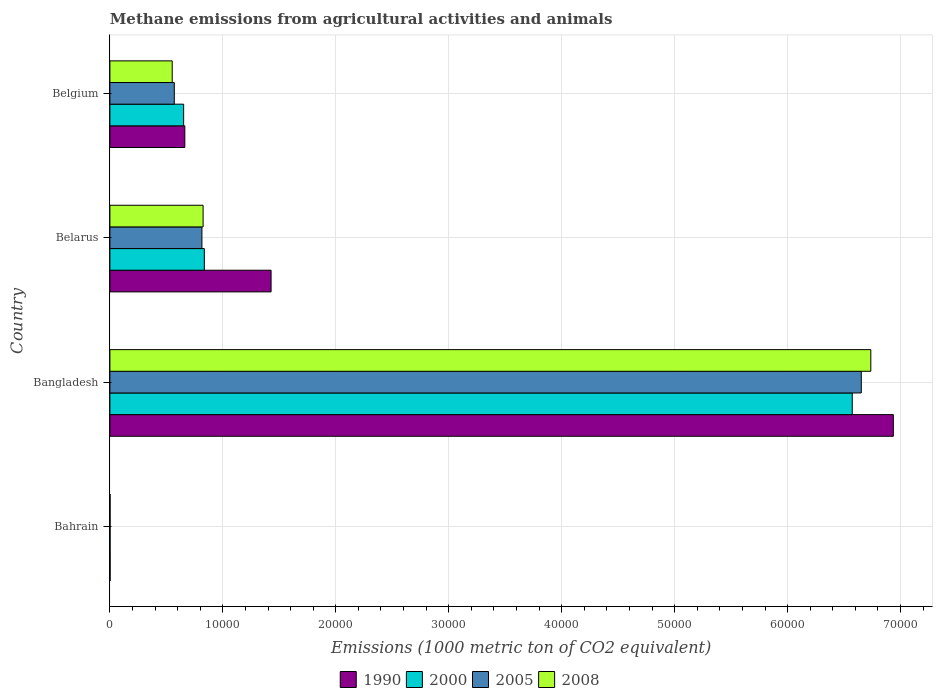How many different coloured bars are there?
Your answer should be compact. 4. Are the number of bars per tick equal to the number of legend labels?
Ensure brevity in your answer.  Yes. Are the number of bars on each tick of the Y-axis equal?
Keep it short and to the point. Yes. How many bars are there on the 2nd tick from the top?
Provide a short and direct response. 4. In how many cases, is the number of bars for a given country not equal to the number of legend labels?
Your answer should be compact. 0. What is the amount of methane emitted in 2008 in Bangladesh?
Your answer should be compact. 6.74e+04. Across all countries, what is the maximum amount of methane emitted in 2000?
Make the answer very short. 6.57e+04. In which country was the amount of methane emitted in 2005 maximum?
Offer a terse response. Bangladesh. In which country was the amount of methane emitted in 1990 minimum?
Make the answer very short. Bahrain. What is the total amount of methane emitted in 2005 in the graph?
Give a very brief answer. 8.04e+04. What is the difference between the amount of methane emitted in 2000 in Bangladesh and that in Belarus?
Make the answer very short. 5.74e+04. What is the difference between the amount of methane emitted in 2005 in Bahrain and the amount of methane emitted in 2000 in Belarus?
Your response must be concise. -8342.9. What is the average amount of methane emitted in 2000 per country?
Provide a short and direct response. 2.02e+04. What is the difference between the amount of methane emitted in 2008 and amount of methane emitted in 2005 in Belarus?
Provide a succinct answer. 104.3. In how many countries, is the amount of methane emitted in 2000 greater than 22000 1000 metric ton?
Offer a very short reply. 1. What is the ratio of the amount of methane emitted in 2000 in Bahrain to that in Belgium?
Offer a very short reply. 0. Is the difference between the amount of methane emitted in 2008 in Bangladesh and Belgium greater than the difference between the amount of methane emitted in 2005 in Bangladesh and Belgium?
Your answer should be compact. Yes. What is the difference between the highest and the second highest amount of methane emitted in 2005?
Offer a very short reply. 5.84e+04. What is the difference between the highest and the lowest amount of methane emitted in 2000?
Offer a very short reply. 6.57e+04. Is the sum of the amount of methane emitted in 2000 in Bangladesh and Belgium greater than the maximum amount of methane emitted in 1990 across all countries?
Your answer should be compact. Yes. Is it the case that in every country, the sum of the amount of methane emitted in 1990 and amount of methane emitted in 2005 is greater than the sum of amount of methane emitted in 2000 and amount of methane emitted in 2008?
Your response must be concise. No. What does the 2nd bar from the top in Bangladesh represents?
Give a very brief answer. 2005. How many bars are there?
Keep it short and to the point. 16. How many countries are there in the graph?
Keep it short and to the point. 4. What is the difference between two consecutive major ticks on the X-axis?
Offer a very short reply. 10000. Does the graph contain any zero values?
Make the answer very short. No. Does the graph contain grids?
Keep it short and to the point. Yes. What is the title of the graph?
Make the answer very short. Methane emissions from agricultural activities and animals. Does "1985" appear as one of the legend labels in the graph?
Ensure brevity in your answer.  No. What is the label or title of the X-axis?
Offer a terse response. Emissions (1000 metric ton of CO2 equivalent). What is the label or title of the Y-axis?
Provide a short and direct response. Country. What is the Emissions (1000 metric ton of CO2 equivalent) of 2005 in Bahrain?
Keep it short and to the point. 17.5. What is the Emissions (1000 metric ton of CO2 equivalent) in 2008 in Bahrain?
Offer a very short reply. 16.2. What is the Emissions (1000 metric ton of CO2 equivalent) in 1990 in Bangladesh?
Your answer should be compact. 6.94e+04. What is the Emissions (1000 metric ton of CO2 equivalent) of 2000 in Bangladesh?
Provide a succinct answer. 6.57e+04. What is the Emissions (1000 metric ton of CO2 equivalent) of 2005 in Bangladesh?
Your answer should be very brief. 6.65e+04. What is the Emissions (1000 metric ton of CO2 equivalent) in 2008 in Bangladesh?
Your answer should be very brief. 6.74e+04. What is the Emissions (1000 metric ton of CO2 equivalent) of 1990 in Belarus?
Keep it short and to the point. 1.43e+04. What is the Emissions (1000 metric ton of CO2 equivalent) in 2000 in Belarus?
Make the answer very short. 8360.4. What is the Emissions (1000 metric ton of CO2 equivalent) of 2005 in Belarus?
Ensure brevity in your answer.  8147.7. What is the Emissions (1000 metric ton of CO2 equivalent) in 2008 in Belarus?
Give a very brief answer. 8252. What is the Emissions (1000 metric ton of CO2 equivalent) of 1990 in Belgium?
Make the answer very short. 6634.3. What is the Emissions (1000 metric ton of CO2 equivalent) in 2000 in Belgium?
Make the answer very short. 6529.5. What is the Emissions (1000 metric ton of CO2 equivalent) of 2005 in Belgium?
Provide a short and direct response. 5701.8. What is the Emissions (1000 metric ton of CO2 equivalent) of 2008 in Belgium?
Your answer should be very brief. 5517.1. Across all countries, what is the maximum Emissions (1000 metric ton of CO2 equivalent) in 1990?
Provide a succinct answer. 6.94e+04. Across all countries, what is the maximum Emissions (1000 metric ton of CO2 equivalent) of 2000?
Your response must be concise. 6.57e+04. Across all countries, what is the maximum Emissions (1000 metric ton of CO2 equivalent) of 2005?
Your response must be concise. 6.65e+04. Across all countries, what is the maximum Emissions (1000 metric ton of CO2 equivalent) of 2008?
Provide a short and direct response. 6.74e+04. Across all countries, what is the minimum Emissions (1000 metric ton of CO2 equivalent) of 1990?
Make the answer very short. 19.5. Across all countries, what is the minimum Emissions (1000 metric ton of CO2 equivalent) in 2000?
Provide a succinct answer. 18.5. Across all countries, what is the minimum Emissions (1000 metric ton of CO2 equivalent) of 2005?
Ensure brevity in your answer.  17.5. What is the total Emissions (1000 metric ton of CO2 equivalent) in 1990 in the graph?
Give a very brief answer. 9.03e+04. What is the total Emissions (1000 metric ton of CO2 equivalent) of 2000 in the graph?
Your answer should be very brief. 8.06e+04. What is the total Emissions (1000 metric ton of CO2 equivalent) of 2005 in the graph?
Ensure brevity in your answer.  8.04e+04. What is the total Emissions (1000 metric ton of CO2 equivalent) of 2008 in the graph?
Give a very brief answer. 8.11e+04. What is the difference between the Emissions (1000 metric ton of CO2 equivalent) of 1990 in Bahrain and that in Bangladesh?
Your answer should be compact. -6.93e+04. What is the difference between the Emissions (1000 metric ton of CO2 equivalent) of 2000 in Bahrain and that in Bangladesh?
Make the answer very short. -6.57e+04. What is the difference between the Emissions (1000 metric ton of CO2 equivalent) of 2005 in Bahrain and that in Bangladesh?
Make the answer very short. -6.65e+04. What is the difference between the Emissions (1000 metric ton of CO2 equivalent) in 2008 in Bahrain and that in Bangladesh?
Offer a very short reply. -6.73e+04. What is the difference between the Emissions (1000 metric ton of CO2 equivalent) in 1990 in Bahrain and that in Belarus?
Your response must be concise. -1.43e+04. What is the difference between the Emissions (1000 metric ton of CO2 equivalent) of 2000 in Bahrain and that in Belarus?
Keep it short and to the point. -8341.9. What is the difference between the Emissions (1000 metric ton of CO2 equivalent) of 2005 in Bahrain and that in Belarus?
Offer a terse response. -8130.2. What is the difference between the Emissions (1000 metric ton of CO2 equivalent) in 2008 in Bahrain and that in Belarus?
Your answer should be very brief. -8235.8. What is the difference between the Emissions (1000 metric ton of CO2 equivalent) of 1990 in Bahrain and that in Belgium?
Give a very brief answer. -6614.8. What is the difference between the Emissions (1000 metric ton of CO2 equivalent) in 2000 in Bahrain and that in Belgium?
Your answer should be compact. -6511. What is the difference between the Emissions (1000 metric ton of CO2 equivalent) of 2005 in Bahrain and that in Belgium?
Ensure brevity in your answer.  -5684.3. What is the difference between the Emissions (1000 metric ton of CO2 equivalent) of 2008 in Bahrain and that in Belgium?
Your answer should be compact. -5500.9. What is the difference between the Emissions (1000 metric ton of CO2 equivalent) of 1990 in Bangladesh and that in Belarus?
Give a very brief answer. 5.51e+04. What is the difference between the Emissions (1000 metric ton of CO2 equivalent) in 2000 in Bangladesh and that in Belarus?
Your response must be concise. 5.74e+04. What is the difference between the Emissions (1000 metric ton of CO2 equivalent) of 2005 in Bangladesh and that in Belarus?
Ensure brevity in your answer.  5.84e+04. What is the difference between the Emissions (1000 metric ton of CO2 equivalent) of 2008 in Bangladesh and that in Belarus?
Ensure brevity in your answer.  5.91e+04. What is the difference between the Emissions (1000 metric ton of CO2 equivalent) of 1990 in Bangladesh and that in Belgium?
Provide a succinct answer. 6.27e+04. What is the difference between the Emissions (1000 metric ton of CO2 equivalent) of 2000 in Bangladesh and that in Belgium?
Give a very brief answer. 5.92e+04. What is the difference between the Emissions (1000 metric ton of CO2 equivalent) in 2005 in Bangladesh and that in Belgium?
Offer a terse response. 6.08e+04. What is the difference between the Emissions (1000 metric ton of CO2 equivalent) in 2008 in Bangladesh and that in Belgium?
Your answer should be compact. 6.18e+04. What is the difference between the Emissions (1000 metric ton of CO2 equivalent) in 1990 in Belarus and that in Belgium?
Make the answer very short. 7636. What is the difference between the Emissions (1000 metric ton of CO2 equivalent) in 2000 in Belarus and that in Belgium?
Your answer should be very brief. 1830.9. What is the difference between the Emissions (1000 metric ton of CO2 equivalent) of 2005 in Belarus and that in Belgium?
Your answer should be compact. 2445.9. What is the difference between the Emissions (1000 metric ton of CO2 equivalent) of 2008 in Belarus and that in Belgium?
Provide a succinct answer. 2734.9. What is the difference between the Emissions (1000 metric ton of CO2 equivalent) of 1990 in Bahrain and the Emissions (1000 metric ton of CO2 equivalent) of 2000 in Bangladesh?
Offer a terse response. -6.57e+04. What is the difference between the Emissions (1000 metric ton of CO2 equivalent) of 1990 in Bahrain and the Emissions (1000 metric ton of CO2 equivalent) of 2005 in Bangladesh?
Your answer should be very brief. -6.65e+04. What is the difference between the Emissions (1000 metric ton of CO2 equivalent) of 1990 in Bahrain and the Emissions (1000 metric ton of CO2 equivalent) of 2008 in Bangladesh?
Offer a very short reply. -6.73e+04. What is the difference between the Emissions (1000 metric ton of CO2 equivalent) in 2000 in Bahrain and the Emissions (1000 metric ton of CO2 equivalent) in 2005 in Bangladesh?
Keep it short and to the point. -6.65e+04. What is the difference between the Emissions (1000 metric ton of CO2 equivalent) of 2000 in Bahrain and the Emissions (1000 metric ton of CO2 equivalent) of 2008 in Bangladesh?
Your response must be concise. -6.73e+04. What is the difference between the Emissions (1000 metric ton of CO2 equivalent) of 2005 in Bahrain and the Emissions (1000 metric ton of CO2 equivalent) of 2008 in Bangladesh?
Your answer should be compact. -6.73e+04. What is the difference between the Emissions (1000 metric ton of CO2 equivalent) in 1990 in Bahrain and the Emissions (1000 metric ton of CO2 equivalent) in 2000 in Belarus?
Your response must be concise. -8340.9. What is the difference between the Emissions (1000 metric ton of CO2 equivalent) in 1990 in Bahrain and the Emissions (1000 metric ton of CO2 equivalent) in 2005 in Belarus?
Make the answer very short. -8128.2. What is the difference between the Emissions (1000 metric ton of CO2 equivalent) of 1990 in Bahrain and the Emissions (1000 metric ton of CO2 equivalent) of 2008 in Belarus?
Give a very brief answer. -8232.5. What is the difference between the Emissions (1000 metric ton of CO2 equivalent) of 2000 in Bahrain and the Emissions (1000 metric ton of CO2 equivalent) of 2005 in Belarus?
Offer a very short reply. -8129.2. What is the difference between the Emissions (1000 metric ton of CO2 equivalent) of 2000 in Bahrain and the Emissions (1000 metric ton of CO2 equivalent) of 2008 in Belarus?
Ensure brevity in your answer.  -8233.5. What is the difference between the Emissions (1000 metric ton of CO2 equivalent) of 2005 in Bahrain and the Emissions (1000 metric ton of CO2 equivalent) of 2008 in Belarus?
Your answer should be compact. -8234.5. What is the difference between the Emissions (1000 metric ton of CO2 equivalent) of 1990 in Bahrain and the Emissions (1000 metric ton of CO2 equivalent) of 2000 in Belgium?
Offer a very short reply. -6510. What is the difference between the Emissions (1000 metric ton of CO2 equivalent) of 1990 in Bahrain and the Emissions (1000 metric ton of CO2 equivalent) of 2005 in Belgium?
Ensure brevity in your answer.  -5682.3. What is the difference between the Emissions (1000 metric ton of CO2 equivalent) in 1990 in Bahrain and the Emissions (1000 metric ton of CO2 equivalent) in 2008 in Belgium?
Keep it short and to the point. -5497.6. What is the difference between the Emissions (1000 metric ton of CO2 equivalent) of 2000 in Bahrain and the Emissions (1000 metric ton of CO2 equivalent) of 2005 in Belgium?
Offer a terse response. -5683.3. What is the difference between the Emissions (1000 metric ton of CO2 equivalent) in 2000 in Bahrain and the Emissions (1000 metric ton of CO2 equivalent) in 2008 in Belgium?
Provide a succinct answer. -5498.6. What is the difference between the Emissions (1000 metric ton of CO2 equivalent) of 2005 in Bahrain and the Emissions (1000 metric ton of CO2 equivalent) of 2008 in Belgium?
Keep it short and to the point. -5499.6. What is the difference between the Emissions (1000 metric ton of CO2 equivalent) in 1990 in Bangladesh and the Emissions (1000 metric ton of CO2 equivalent) in 2000 in Belarus?
Offer a very short reply. 6.10e+04. What is the difference between the Emissions (1000 metric ton of CO2 equivalent) in 1990 in Bangladesh and the Emissions (1000 metric ton of CO2 equivalent) in 2005 in Belarus?
Provide a short and direct response. 6.12e+04. What is the difference between the Emissions (1000 metric ton of CO2 equivalent) of 1990 in Bangladesh and the Emissions (1000 metric ton of CO2 equivalent) of 2008 in Belarus?
Keep it short and to the point. 6.11e+04. What is the difference between the Emissions (1000 metric ton of CO2 equivalent) of 2000 in Bangladesh and the Emissions (1000 metric ton of CO2 equivalent) of 2005 in Belarus?
Offer a very short reply. 5.76e+04. What is the difference between the Emissions (1000 metric ton of CO2 equivalent) in 2000 in Bangladesh and the Emissions (1000 metric ton of CO2 equivalent) in 2008 in Belarus?
Offer a terse response. 5.75e+04. What is the difference between the Emissions (1000 metric ton of CO2 equivalent) of 2005 in Bangladesh and the Emissions (1000 metric ton of CO2 equivalent) of 2008 in Belarus?
Offer a very short reply. 5.83e+04. What is the difference between the Emissions (1000 metric ton of CO2 equivalent) in 1990 in Bangladesh and the Emissions (1000 metric ton of CO2 equivalent) in 2000 in Belgium?
Provide a succinct answer. 6.28e+04. What is the difference between the Emissions (1000 metric ton of CO2 equivalent) of 1990 in Bangladesh and the Emissions (1000 metric ton of CO2 equivalent) of 2005 in Belgium?
Provide a succinct answer. 6.37e+04. What is the difference between the Emissions (1000 metric ton of CO2 equivalent) in 1990 in Bangladesh and the Emissions (1000 metric ton of CO2 equivalent) in 2008 in Belgium?
Your answer should be compact. 6.38e+04. What is the difference between the Emissions (1000 metric ton of CO2 equivalent) of 2000 in Bangladesh and the Emissions (1000 metric ton of CO2 equivalent) of 2005 in Belgium?
Offer a terse response. 6.00e+04. What is the difference between the Emissions (1000 metric ton of CO2 equivalent) of 2000 in Bangladesh and the Emissions (1000 metric ton of CO2 equivalent) of 2008 in Belgium?
Ensure brevity in your answer.  6.02e+04. What is the difference between the Emissions (1000 metric ton of CO2 equivalent) in 2005 in Bangladesh and the Emissions (1000 metric ton of CO2 equivalent) in 2008 in Belgium?
Make the answer very short. 6.10e+04. What is the difference between the Emissions (1000 metric ton of CO2 equivalent) of 1990 in Belarus and the Emissions (1000 metric ton of CO2 equivalent) of 2000 in Belgium?
Give a very brief answer. 7740.8. What is the difference between the Emissions (1000 metric ton of CO2 equivalent) of 1990 in Belarus and the Emissions (1000 metric ton of CO2 equivalent) of 2005 in Belgium?
Your answer should be very brief. 8568.5. What is the difference between the Emissions (1000 metric ton of CO2 equivalent) in 1990 in Belarus and the Emissions (1000 metric ton of CO2 equivalent) in 2008 in Belgium?
Provide a succinct answer. 8753.2. What is the difference between the Emissions (1000 metric ton of CO2 equivalent) in 2000 in Belarus and the Emissions (1000 metric ton of CO2 equivalent) in 2005 in Belgium?
Make the answer very short. 2658.6. What is the difference between the Emissions (1000 metric ton of CO2 equivalent) of 2000 in Belarus and the Emissions (1000 metric ton of CO2 equivalent) of 2008 in Belgium?
Offer a very short reply. 2843.3. What is the difference between the Emissions (1000 metric ton of CO2 equivalent) of 2005 in Belarus and the Emissions (1000 metric ton of CO2 equivalent) of 2008 in Belgium?
Offer a terse response. 2630.6. What is the average Emissions (1000 metric ton of CO2 equivalent) in 1990 per country?
Provide a short and direct response. 2.26e+04. What is the average Emissions (1000 metric ton of CO2 equivalent) in 2000 per country?
Your answer should be compact. 2.02e+04. What is the average Emissions (1000 metric ton of CO2 equivalent) in 2005 per country?
Keep it short and to the point. 2.01e+04. What is the average Emissions (1000 metric ton of CO2 equivalent) of 2008 per country?
Offer a very short reply. 2.03e+04. What is the difference between the Emissions (1000 metric ton of CO2 equivalent) in 1990 and Emissions (1000 metric ton of CO2 equivalent) in 2005 in Bahrain?
Provide a succinct answer. 2. What is the difference between the Emissions (1000 metric ton of CO2 equivalent) of 1990 and Emissions (1000 metric ton of CO2 equivalent) of 2008 in Bahrain?
Provide a succinct answer. 3.3. What is the difference between the Emissions (1000 metric ton of CO2 equivalent) of 2000 and Emissions (1000 metric ton of CO2 equivalent) of 2005 in Bahrain?
Give a very brief answer. 1. What is the difference between the Emissions (1000 metric ton of CO2 equivalent) of 2000 and Emissions (1000 metric ton of CO2 equivalent) of 2008 in Bahrain?
Your answer should be compact. 2.3. What is the difference between the Emissions (1000 metric ton of CO2 equivalent) of 2005 and Emissions (1000 metric ton of CO2 equivalent) of 2008 in Bahrain?
Keep it short and to the point. 1.3. What is the difference between the Emissions (1000 metric ton of CO2 equivalent) in 1990 and Emissions (1000 metric ton of CO2 equivalent) in 2000 in Bangladesh?
Your answer should be compact. 3636.5. What is the difference between the Emissions (1000 metric ton of CO2 equivalent) of 1990 and Emissions (1000 metric ton of CO2 equivalent) of 2005 in Bangladesh?
Provide a short and direct response. 2835.6. What is the difference between the Emissions (1000 metric ton of CO2 equivalent) in 1990 and Emissions (1000 metric ton of CO2 equivalent) in 2008 in Bangladesh?
Offer a terse response. 1993. What is the difference between the Emissions (1000 metric ton of CO2 equivalent) of 2000 and Emissions (1000 metric ton of CO2 equivalent) of 2005 in Bangladesh?
Offer a very short reply. -800.9. What is the difference between the Emissions (1000 metric ton of CO2 equivalent) of 2000 and Emissions (1000 metric ton of CO2 equivalent) of 2008 in Bangladesh?
Your answer should be very brief. -1643.5. What is the difference between the Emissions (1000 metric ton of CO2 equivalent) of 2005 and Emissions (1000 metric ton of CO2 equivalent) of 2008 in Bangladesh?
Make the answer very short. -842.6. What is the difference between the Emissions (1000 metric ton of CO2 equivalent) of 1990 and Emissions (1000 metric ton of CO2 equivalent) of 2000 in Belarus?
Your answer should be very brief. 5909.9. What is the difference between the Emissions (1000 metric ton of CO2 equivalent) of 1990 and Emissions (1000 metric ton of CO2 equivalent) of 2005 in Belarus?
Make the answer very short. 6122.6. What is the difference between the Emissions (1000 metric ton of CO2 equivalent) of 1990 and Emissions (1000 metric ton of CO2 equivalent) of 2008 in Belarus?
Your response must be concise. 6018.3. What is the difference between the Emissions (1000 metric ton of CO2 equivalent) of 2000 and Emissions (1000 metric ton of CO2 equivalent) of 2005 in Belarus?
Make the answer very short. 212.7. What is the difference between the Emissions (1000 metric ton of CO2 equivalent) in 2000 and Emissions (1000 metric ton of CO2 equivalent) in 2008 in Belarus?
Your answer should be compact. 108.4. What is the difference between the Emissions (1000 metric ton of CO2 equivalent) of 2005 and Emissions (1000 metric ton of CO2 equivalent) of 2008 in Belarus?
Your response must be concise. -104.3. What is the difference between the Emissions (1000 metric ton of CO2 equivalent) in 1990 and Emissions (1000 metric ton of CO2 equivalent) in 2000 in Belgium?
Your answer should be very brief. 104.8. What is the difference between the Emissions (1000 metric ton of CO2 equivalent) in 1990 and Emissions (1000 metric ton of CO2 equivalent) in 2005 in Belgium?
Provide a short and direct response. 932.5. What is the difference between the Emissions (1000 metric ton of CO2 equivalent) of 1990 and Emissions (1000 metric ton of CO2 equivalent) of 2008 in Belgium?
Provide a short and direct response. 1117.2. What is the difference between the Emissions (1000 metric ton of CO2 equivalent) of 2000 and Emissions (1000 metric ton of CO2 equivalent) of 2005 in Belgium?
Provide a succinct answer. 827.7. What is the difference between the Emissions (1000 metric ton of CO2 equivalent) in 2000 and Emissions (1000 metric ton of CO2 equivalent) in 2008 in Belgium?
Your answer should be compact. 1012.4. What is the difference between the Emissions (1000 metric ton of CO2 equivalent) in 2005 and Emissions (1000 metric ton of CO2 equivalent) in 2008 in Belgium?
Your answer should be compact. 184.7. What is the ratio of the Emissions (1000 metric ton of CO2 equivalent) in 1990 in Bahrain to that in Bangladesh?
Your answer should be compact. 0. What is the ratio of the Emissions (1000 metric ton of CO2 equivalent) of 1990 in Bahrain to that in Belarus?
Offer a terse response. 0. What is the ratio of the Emissions (1000 metric ton of CO2 equivalent) of 2000 in Bahrain to that in Belarus?
Make the answer very short. 0. What is the ratio of the Emissions (1000 metric ton of CO2 equivalent) in 2005 in Bahrain to that in Belarus?
Keep it short and to the point. 0. What is the ratio of the Emissions (1000 metric ton of CO2 equivalent) of 2008 in Bahrain to that in Belarus?
Offer a very short reply. 0. What is the ratio of the Emissions (1000 metric ton of CO2 equivalent) of 1990 in Bahrain to that in Belgium?
Offer a very short reply. 0. What is the ratio of the Emissions (1000 metric ton of CO2 equivalent) of 2000 in Bahrain to that in Belgium?
Your answer should be very brief. 0. What is the ratio of the Emissions (1000 metric ton of CO2 equivalent) in 2005 in Bahrain to that in Belgium?
Give a very brief answer. 0. What is the ratio of the Emissions (1000 metric ton of CO2 equivalent) in 2008 in Bahrain to that in Belgium?
Offer a terse response. 0. What is the ratio of the Emissions (1000 metric ton of CO2 equivalent) of 1990 in Bangladesh to that in Belarus?
Provide a succinct answer. 4.86. What is the ratio of the Emissions (1000 metric ton of CO2 equivalent) in 2000 in Bangladesh to that in Belarus?
Your answer should be compact. 7.86. What is the ratio of the Emissions (1000 metric ton of CO2 equivalent) of 2005 in Bangladesh to that in Belarus?
Your response must be concise. 8.16. What is the ratio of the Emissions (1000 metric ton of CO2 equivalent) of 2008 in Bangladesh to that in Belarus?
Your response must be concise. 8.16. What is the ratio of the Emissions (1000 metric ton of CO2 equivalent) of 1990 in Bangladesh to that in Belgium?
Your response must be concise. 10.45. What is the ratio of the Emissions (1000 metric ton of CO2 equivalent) of 2000 in Bangladesh to that in Belgium?
Ensure brevity in your answer.  10.07. What is the ratio of the Emissions (1000 metric ton of CO2 equivalent) of 2005 in Bangladesh to that in Belgium?
Your response must be concise. 11.67. What is the ratio of the Emissions (1000 metric ton of CO2 equivalent) of 2008 in Bangladesh to that in Belgium?
Give a very brief answer. 12.21. What is the ratio of the Emissions (1000 metric ton of CO2 equivalent) of 1990 in Belarus to that in Belgium?
Provide a succinct answer. 2.15. What is the ratio of the Emissions (1000 metric ton of CO2 equivalent) in 2000 in Belarus to that in Belgium?
Your response must be concise. 1.28. What is the ratio of the Emissions (1000 metric ton of CO2 equivalent) in 2005 in Belarus to that in Belgium?
Make the answer very short. 1.43. What is the ratio of the Emissions (1000 metric ton of CO2 equivalent) of 2008 in Belarus to that in Belgium?
Ensure brevity in your answer.  1.5. What is the difference between the highest and the second highest Emissions (1000 metric ton of CO2 equivalent) in 1990?
Your answer should be compact. 5.51e+04. What is the difference between the highest and the second highest Emissions (1000 metric ton of CO2 equivalent) of 2000?
Your answer should be very brief. 5.74e+04. What is the difference between the highest and the second highest Emissions (1000 metric ton of CO2 equivalent) of 2005?
Ensure brevity in your answer.  5.84e+04. What is the difference between the highest and the second highest Emissions (1000 metric ton of CO2 equivalent) of 2008?
Ensure brevity in your answer.  5.91e+04. What is the difference between the highest and the lowest Emissions (1000 metric ton of CO2 equivalent) of 1990?
Give a very brief answer. 6.93e+04. What is the difference between the highest and the lowest Emissions (1000 metric ton of CO2 equivalent) in 2000?
Your response must be concise. 6.57e+04. What is the difference between the highest and the lowest Emissions (1000 metric ton of CO2 equivalent) of 2005?
Provide a succinct answer. 6.65e+04. What is the difference between the highest and the lowest Emissions (1000 metric ton of CO2 equivalent) in 2008?
Give a very brief answer. 6.73e+04. 